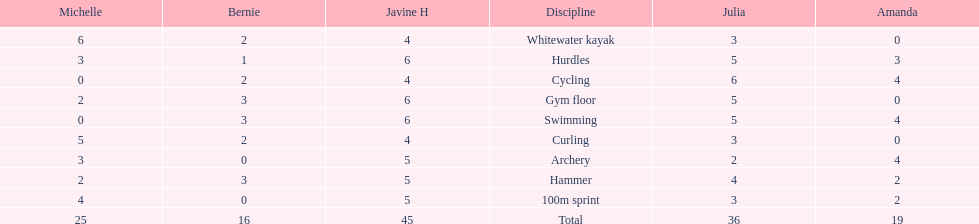What is the first discipline listed on this chart? Whitewater kayak. 